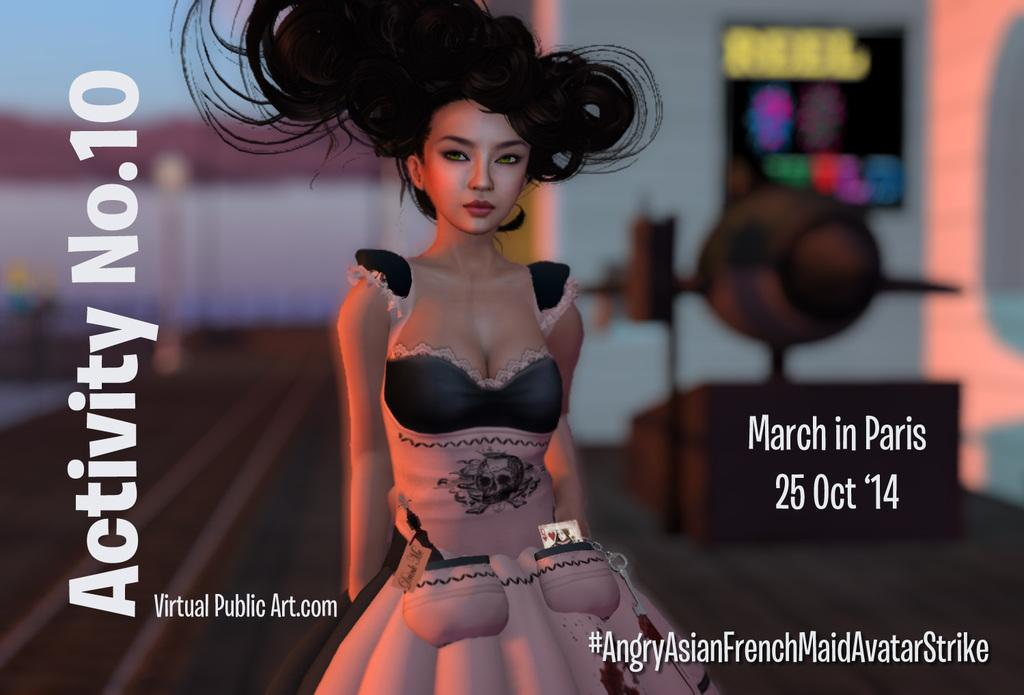Who is present in the image? There is a woman in the image. What can be seen in the image that might indicate its origin or ownership? There is a watermark in the image. How would you describe the background of the image? The background of the image is blurred. What type of structure can be seen in the image? There is a board and a wall in the image. What else can be seen in the image besides the woman and the structures? There are objects in the image. What type of pest can be seen crawling on the woman in the image? There are no pests visible in the image; it only features a woman, a watermark, a blurred background, a board, a wall, and objects. 